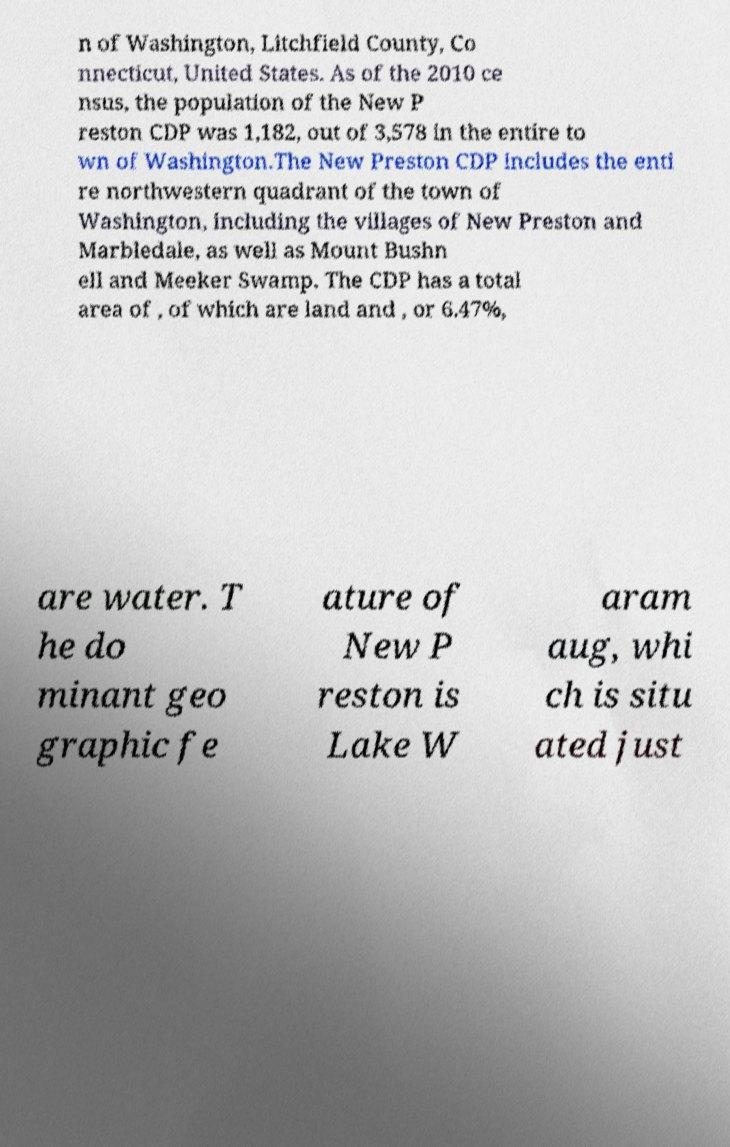Can you read and provide the text displayed in the image?This photo seems to have some interesting text. Can you extract and type it out for me? n of Washington, Litchfield County, Co nnecticut, United States. As of the 2010 ce nsus, the population of the New P reston CDP was 1,182, out of 3,578 in the entire to wn of Washington.The New Preston CDP includes the enti re northwestern quadrant of the town of Washington, including the villages of New Preston and Marbledale, as well as Mount Bushn ell and Meeker Swamp. The CDP has a total area of , of which are land and , or 6.47%, are water. T he do minant geo graphic fe ature of New P reston is Lake W aram aug, whi ch is situ ated just 